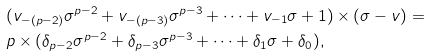Convert formula to latex. <formula><loc_0><loc_0><loc_500><loc_500>& ( v _ { - ( p - 2 ) } \sigma ^ { p - 2 } + v _ { - ( p - 3 ) } \sigma ^ { p - 3 } + \dots + v _ { - 1 } \sigma + 1 ) \times ( \sigma - v ) = \\ & p \times ( \delta _ { p - 2 } \sigma ^ { p - 2 } + \delta _ { p - 3 } \sigma ^ { p - 3 } + \dots + \delta _ { 1 } \sigma + \delta _ { 0 } ) , \\</formula> 